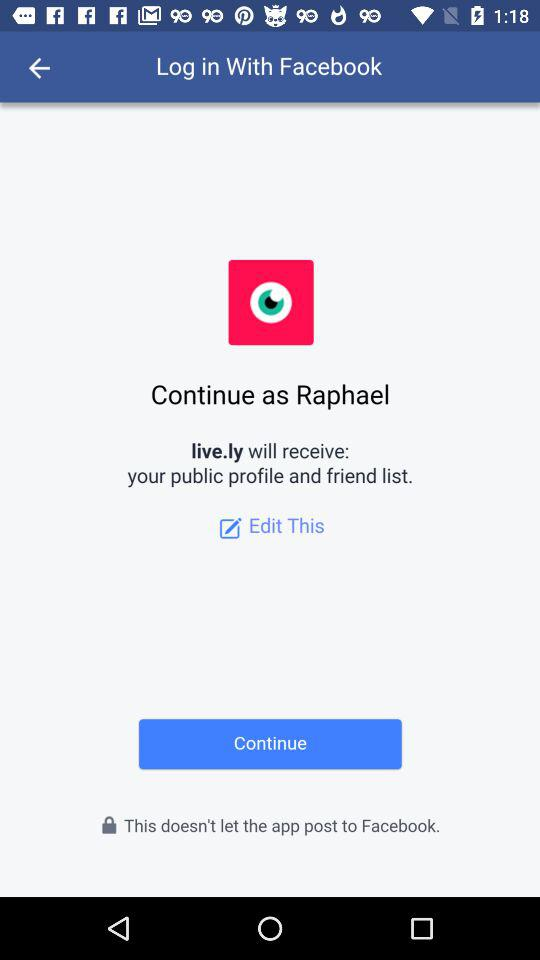What application is requesting access permission? The application is "live.ly". 